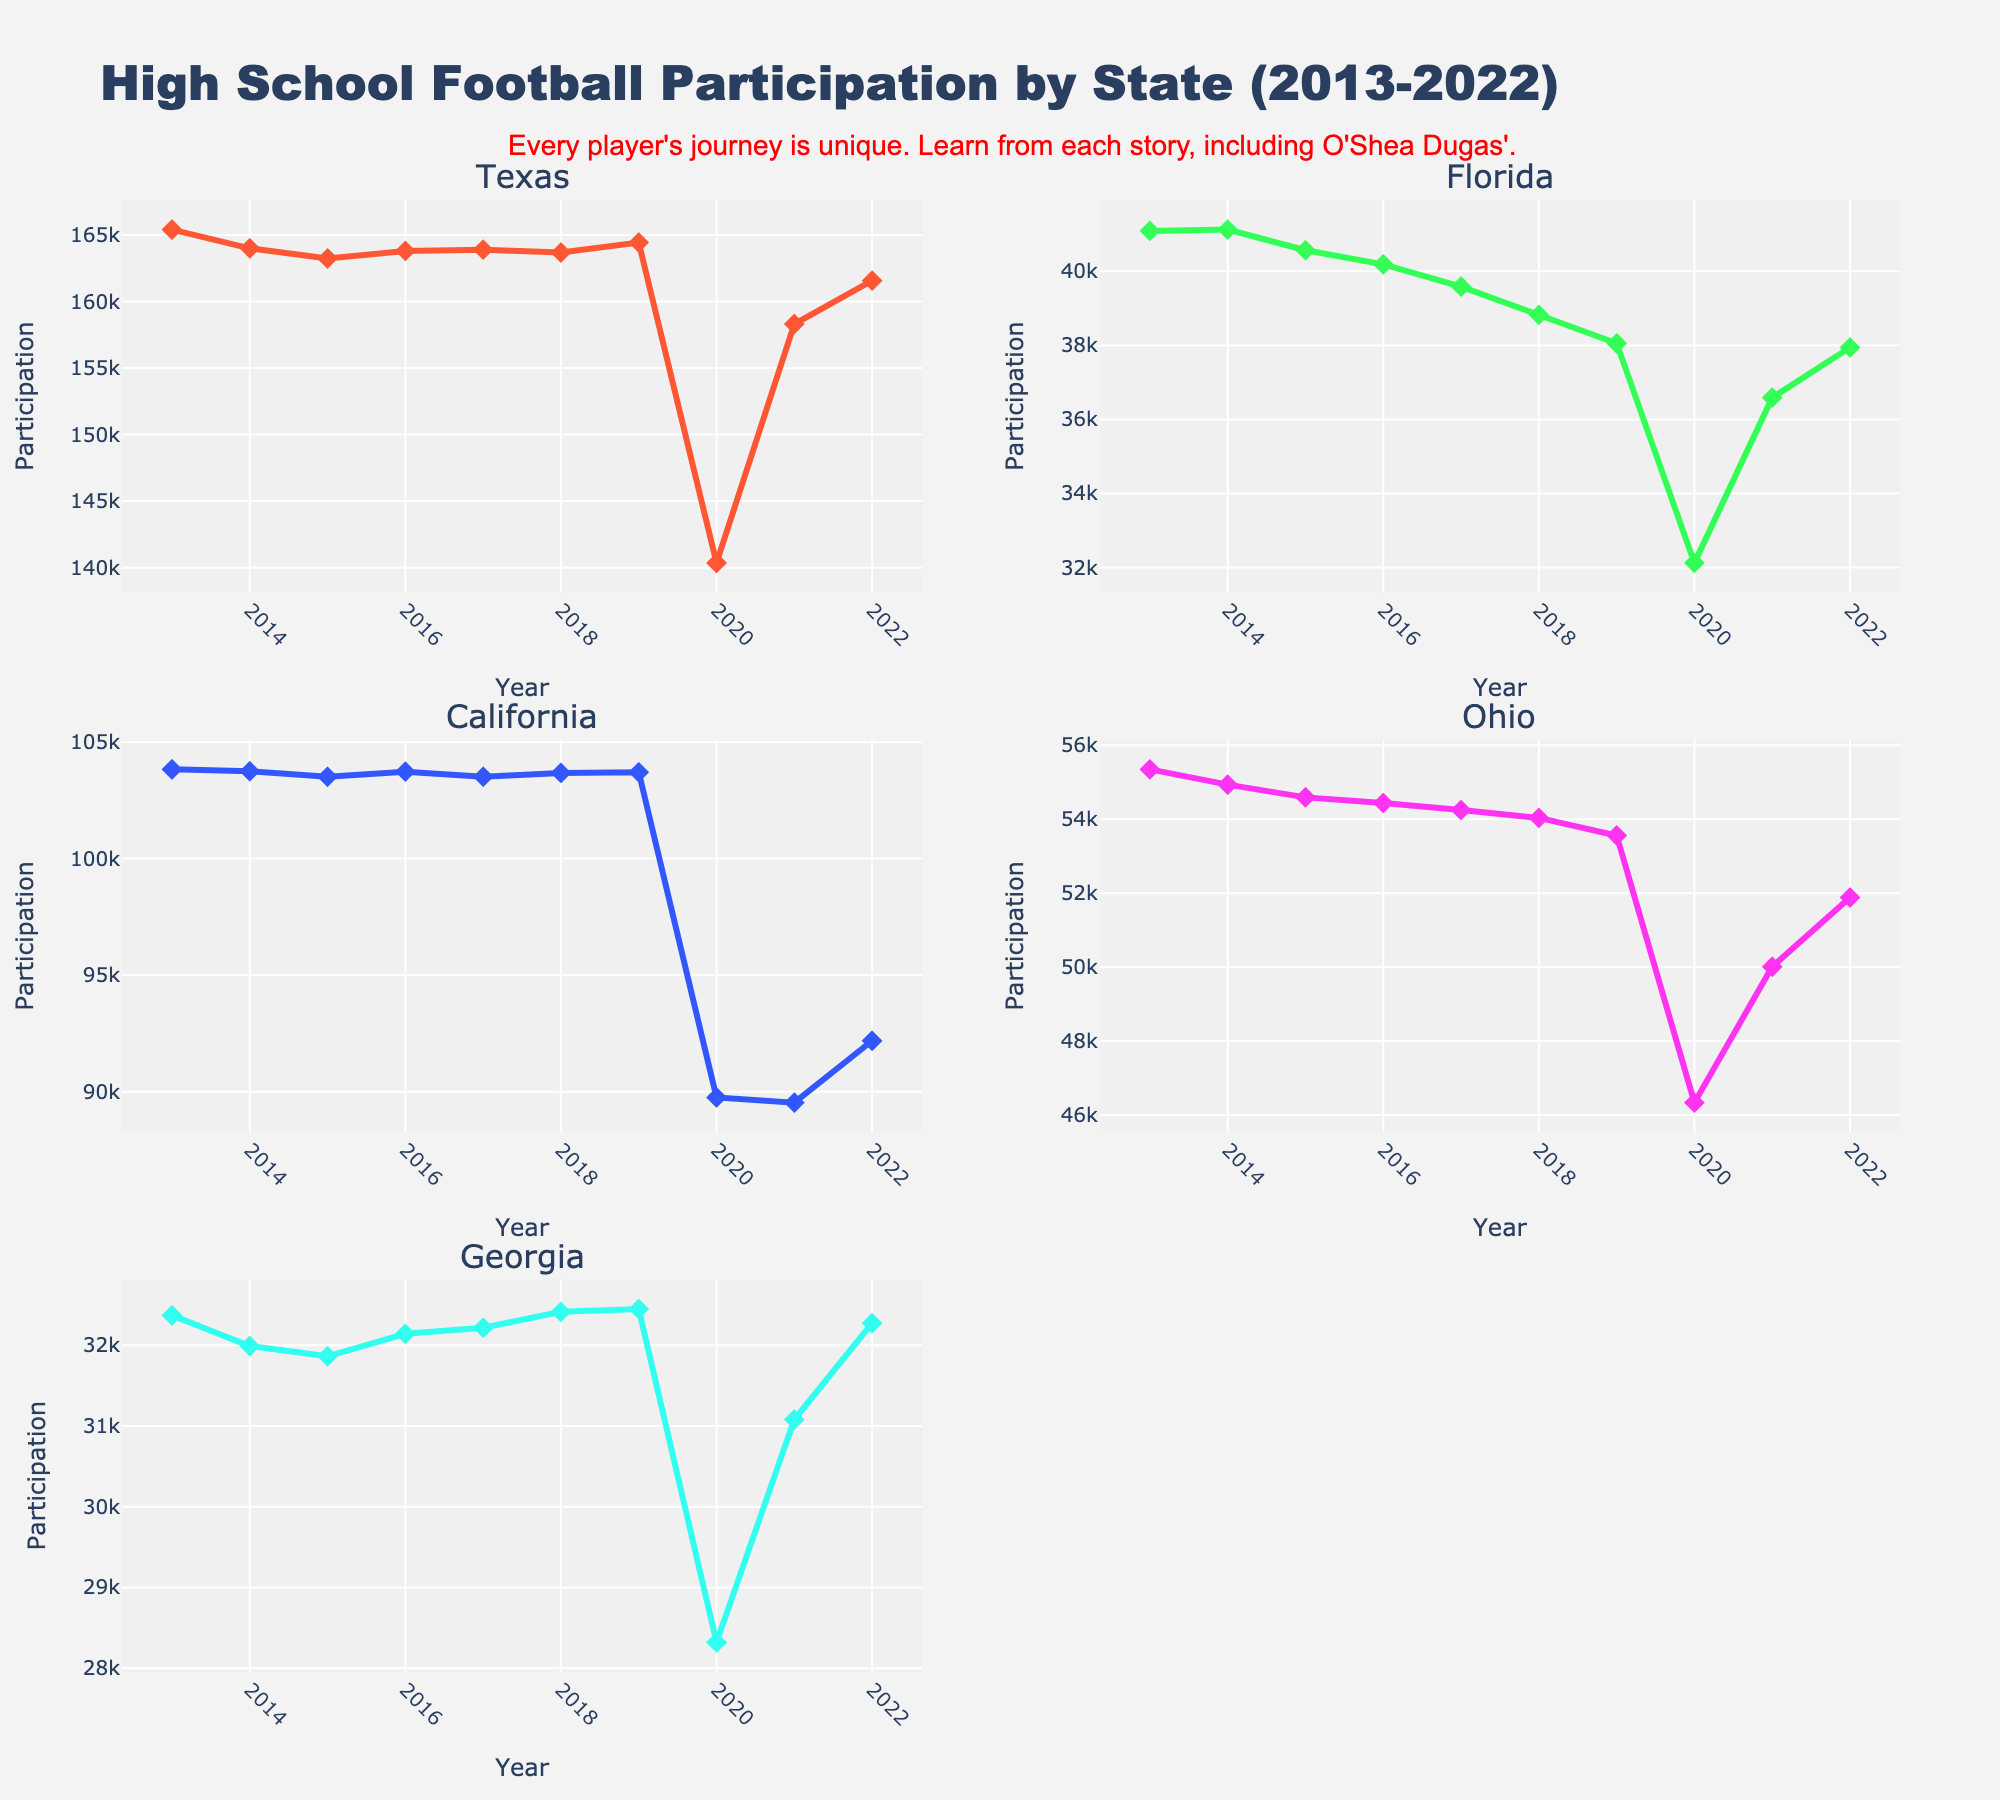What's the title of the figure? The title of the figure is prominently displayed at the top center of the figure.
Answer: High School Football Participation by State (2013-2022) How many subplots are in the figure? By counting the number of distinct smaller plots within the main figure, we determine the total number. There are three rows and two columns, making six subplots.
Answer: 6 Which state has the most participation in high school football in 2022 based on the figure? Look at the end of each line corresponding to the year 2022. The state with the highest value in 2022 is Texas.
Answer: Texas What was the participation trend for California from 2013 to 2020? For California, trace the line from the year 2013 to 2020. The line decreases sharply, especially from 2019 to 2020.
Answer: Decreasing Which state had the least participation in high school football in 2020? Examine the lines at the year 2020 and find the one with the smallest value. Georgia has the lowest value in 2020.
Answer: Georgia How did participation in Texas change from 2019 to 2020? Look at the line corresponding to Texas and compare the values at 2019 and 2020. Participation in Texas decreased sharply from 164,433 to 140,356.
Answer: Decreased sharply Which state shows the most significant drop in participation between 2019 and 2020? Compare the differences in values between 2019 and 2020 for each state. California shows the largest drop from 103702 to 89756, a drop of 13946.
Answer: California In which year did Georgia see the highest participation? For Georgia's subplot, trace along the years and identify the highest value, which appears in 2019.
Answer: 2019 Compare the participation trends for Texas and Florida from 2013 to 2018. Look at the lines for Texas and Florida from 2013 to 2018. Texas remains relatively stable, while Florida shows a consistent decrease.
Answer: Texas stable, Florida decreased 